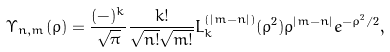<formula> <loc_0><loc_0><loc_500><loc_500>\Upsilon _ { n , m } ( \rho ) = \frac { ( - ) ^ { k } } { \sqrt { \pi } } \frac { k ! } { \sqrt { n ! } \sqrt { m ! } } L _ { k } ^ { ( | m - n | ) } ( \rho ^ { 2 } ) \rho ^ { | m - n | } e ^ { - \rho ^ { 2 } / 2 } ,</formula> 